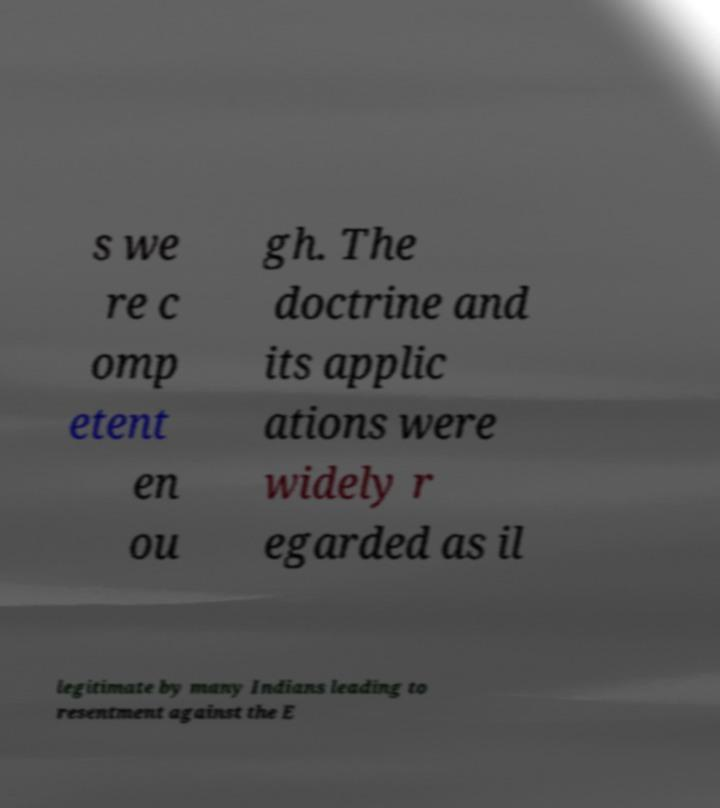Please read and relay the text visible in this image. What does it say? s we re c omp etent en ou gh. The doctrine and its applic ations were widely r egarded as il legitimate by many Indians leading to resentment against the E 